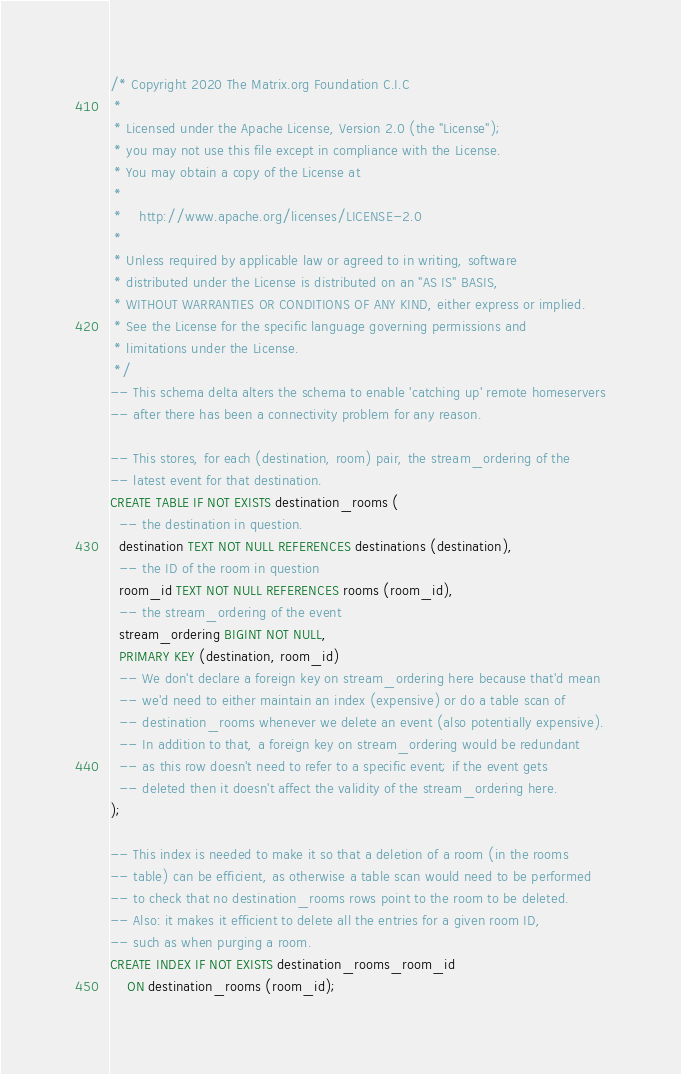<code> <loc_0><loc_0><loc_500><loc_500><_SQL_>/* Copyright 2020 The Matrix.org Foundation C.I.C
 *
 * Licensed under the Apache License, Version 2.0 (the "License");
 * you may not use this file except in compliance with the License.
 * You may obtain a copy of the License at
 *
 *    http://www.apache.org/licenses/LICENSE-2.0
 *
 * Unless required by applicable law or agreed to in writing, software
 * distributed under the License is distributed on an "AS IS" BASIS,
 * WITHOUT WARRANTIES OR CONDITIONS OF ANY KIND, either express or implied.
 * See the License for the specific language governing permissions and
 * limitations under the License.
 */
-- This schema delta alters the schema to enable 'catching up' remote homeservers
-- after there has been a connectivity problem for any reason.

-- This stores, for each (destination, room) pair, the stream_ordering of the
-- latest event for that destination.
CREATE TABLE IF NOT EXISTS destination_rooms (
  -- the destination in question.
  destination TEXT NOT NULL REFERENCES destinations (destination),
  -- the ID of the room in question
  room_id TEXT NOT NULL REFERENCES rooms (room_id),
  -- the stream_ordering of the event
  stream_ordering BIGINT NOT NULL,
  PRIMARY KEY (destination, room_id)
  -- We don't declare a foreign key on stream_ordering here because that'd mean
  -- we'd need to either maintain an index (expensive) or do a table scan of
  -- destination_rooms whenever we delete an event (also potentially expensive).
  -- In addition to that, a foreign key on stream_ordering would be redundant
  -- as this row doesn't need to refer to a specific event; if the event gets
  -- deleted then it doesn't affect the validity of the stream_ordering here.
);

-- This index is needed to make it so that a deletion of a room (in the rooms
-- table) can be efficient, as otherwise a table scan would need to be performed
-- to check that no destination_rooms rows point to the room to be deleted.
-- Also: it makes it efficient to delete all the entries for a given room ID,
-- such as when purging a room.
CREATE INDEX IF NOT EXISTS destination_rooms_room_id
    ON destination_rooms (room_id);
</code> 